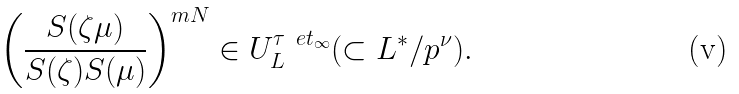<formula> <loc_0><loc_0><loc_500><loc_500>\left ( \frac { S ( \zeta \mu ) } { S ( \zeta ) S ( \mu ) } \right ) ^ { m N } \in U ^ { \tau ^ { \ } e t _ { \infty } } _ { L } ( \subset L ^ { * } / p ^ { \nu } ) .</formula> 